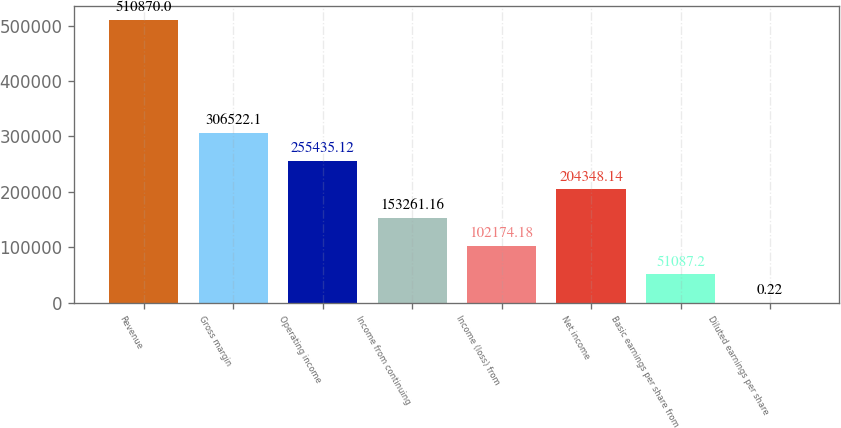<chart> <loc_0><loc_0><loc_500><loc_500><bar_chart><fcel>Revenue<fcel>Gross margin<fcel>Operating income<fcel>Income from continuing<fcel>Income (loss) from<fcel>Net income<fcel>Basic earnings per share from<fcel>Diluted earnings per share<nl><fcel>510870<fcel>306522<fcel>255435<fcel>153261<fcel>102174<fcel>204348<fcel>51087.2<fcel>0.22<nl></chart> 